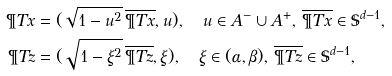Convert formula to latex. <formula><loc_0><loc_0><loc_500><loc_500>\P T { x } & = ( \sqrt { 1 - u ^ { 2 } } \, \overline { \P T { x } } , u ) , \quad u \in A ^ { - } \cup A ^ { + } , \, \overline { \P T { x } } \in \mathbb { S } ^ { d - 1 } , \\ \P T { z } & = ( \sqrt { 1 - \xi ^ { 2 } } \, \overline { \P T { z } } , \xi ) , \quad \xi \in ( \alpha , \beta ) , \, \overline { \P T { z } } \in \mathbb { S } ^ { d - 1 } ,</formula> 